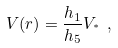<formula> <loc_0><loc_0><loc_500><loc_500>V ( r ) = \frac { h _ { 1 } } { h _ { 5 } } V _ { ^ { * } } \ , \label l { V i n s i d e }</formula> 